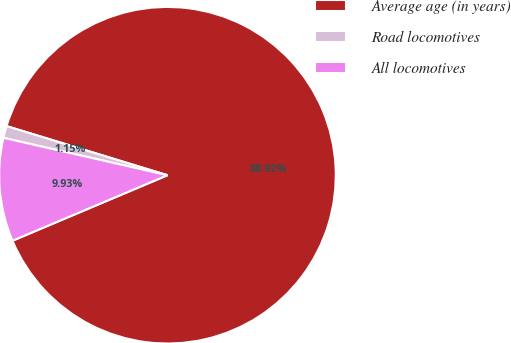<chart> <loc_0><loc_0><loc_500><loc_500><pie_chart><fcel>Average age (in years)<fcel>Road locomotives<fcel>All locomotives<nl><fcel>88.92%<fcel>1.15%<fcel>9.93%<nl></chart> 